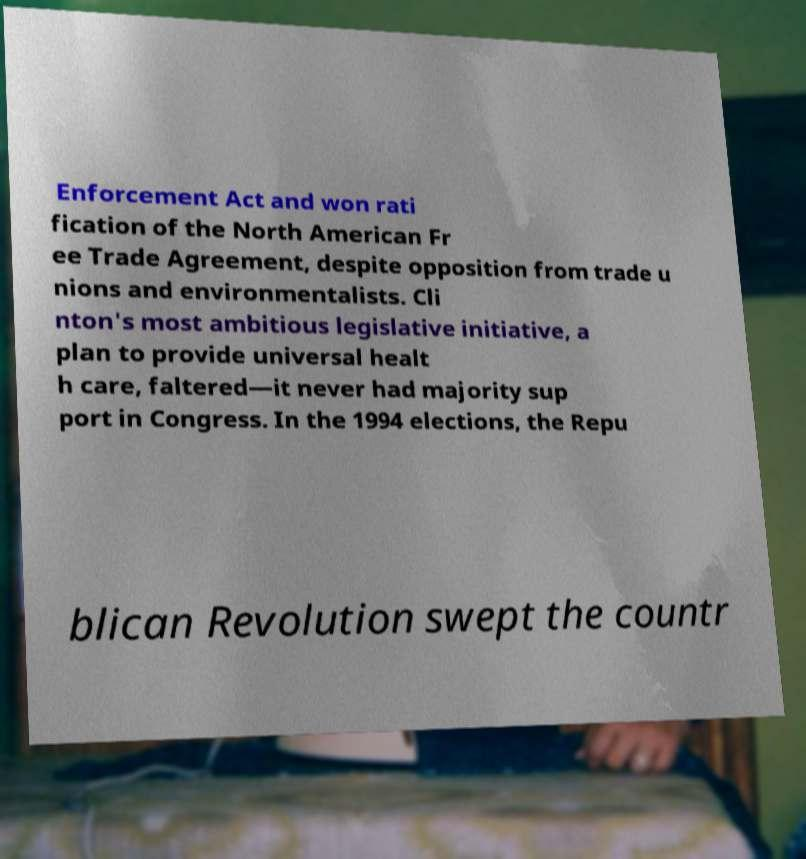There's text embedded in this image that I need extracted. Can you transcribe it verbatim? Enforcement Act and won rati fication of the North American Fr ee Trade Agreement, despite opposition from trade u nions and environmentalists. Cli nton's most ambitious legislative initiative, a plan to provide universal healt h care, faltered—it never had majority sup port in Congress. In the 1994 elections, the Repu blican Revolution swept the countr 